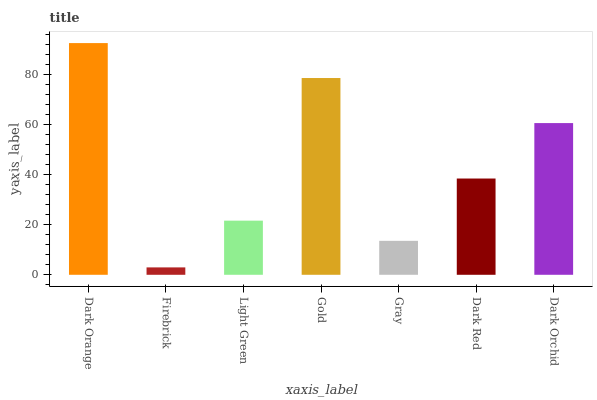Is Firebrick the minimum?
Answer yes or no. Yes. Is Dark Orange the maximum?
Answer yes or no. Yes. Is Light Green the minimum?
Answer yes or no. No. Is Light Green the maximum?
Answer yes or no. No. Is Light Green greater than Firebrick?
Answer yes or no. Yes. Is Firebrick less than Light Green?
Answer yes or no. Yes. Is Firebrick greater than Light Green?
Answer yes or no. No. Is Light Green less than Firebrick?
Answer yes or no. No. Is Dark Red the high median?
Answer yes or no. Yes. Is Dark Red the low median?
Answer yes or no. Yes. Is Light Green the high median?
Answer yes or no. No. Is Gold the low median?
Answer yes or no. No. 